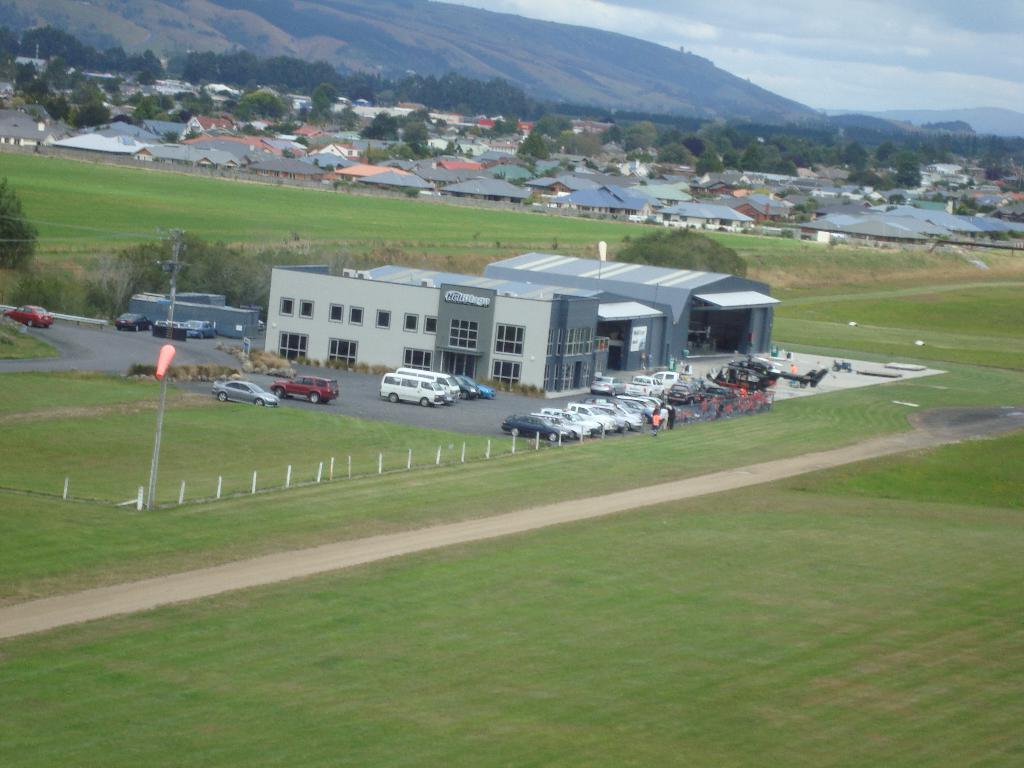What type of natural environment is visible in the image? There is grass in the image, which suggests a natural environment. What type of structure can be seen in the image? There is a fence in the image, which is a type of structure. What type of man-made structures can be seen in the image? There are cars, buildings, houses, and hills visible in the image. What part of the natural environment is visible in the image? Trees are visible in the image. What is visible in the background of the image? The sky is visible in the image. What type of caption is written on the grass in the image? There is no caption written on the grass in the image. What type of trick can be seen being performed in the image? There is no trick being performed in the image. What type of patch is visible on the fence in the image? There is no patch visible on the fence in the image. 